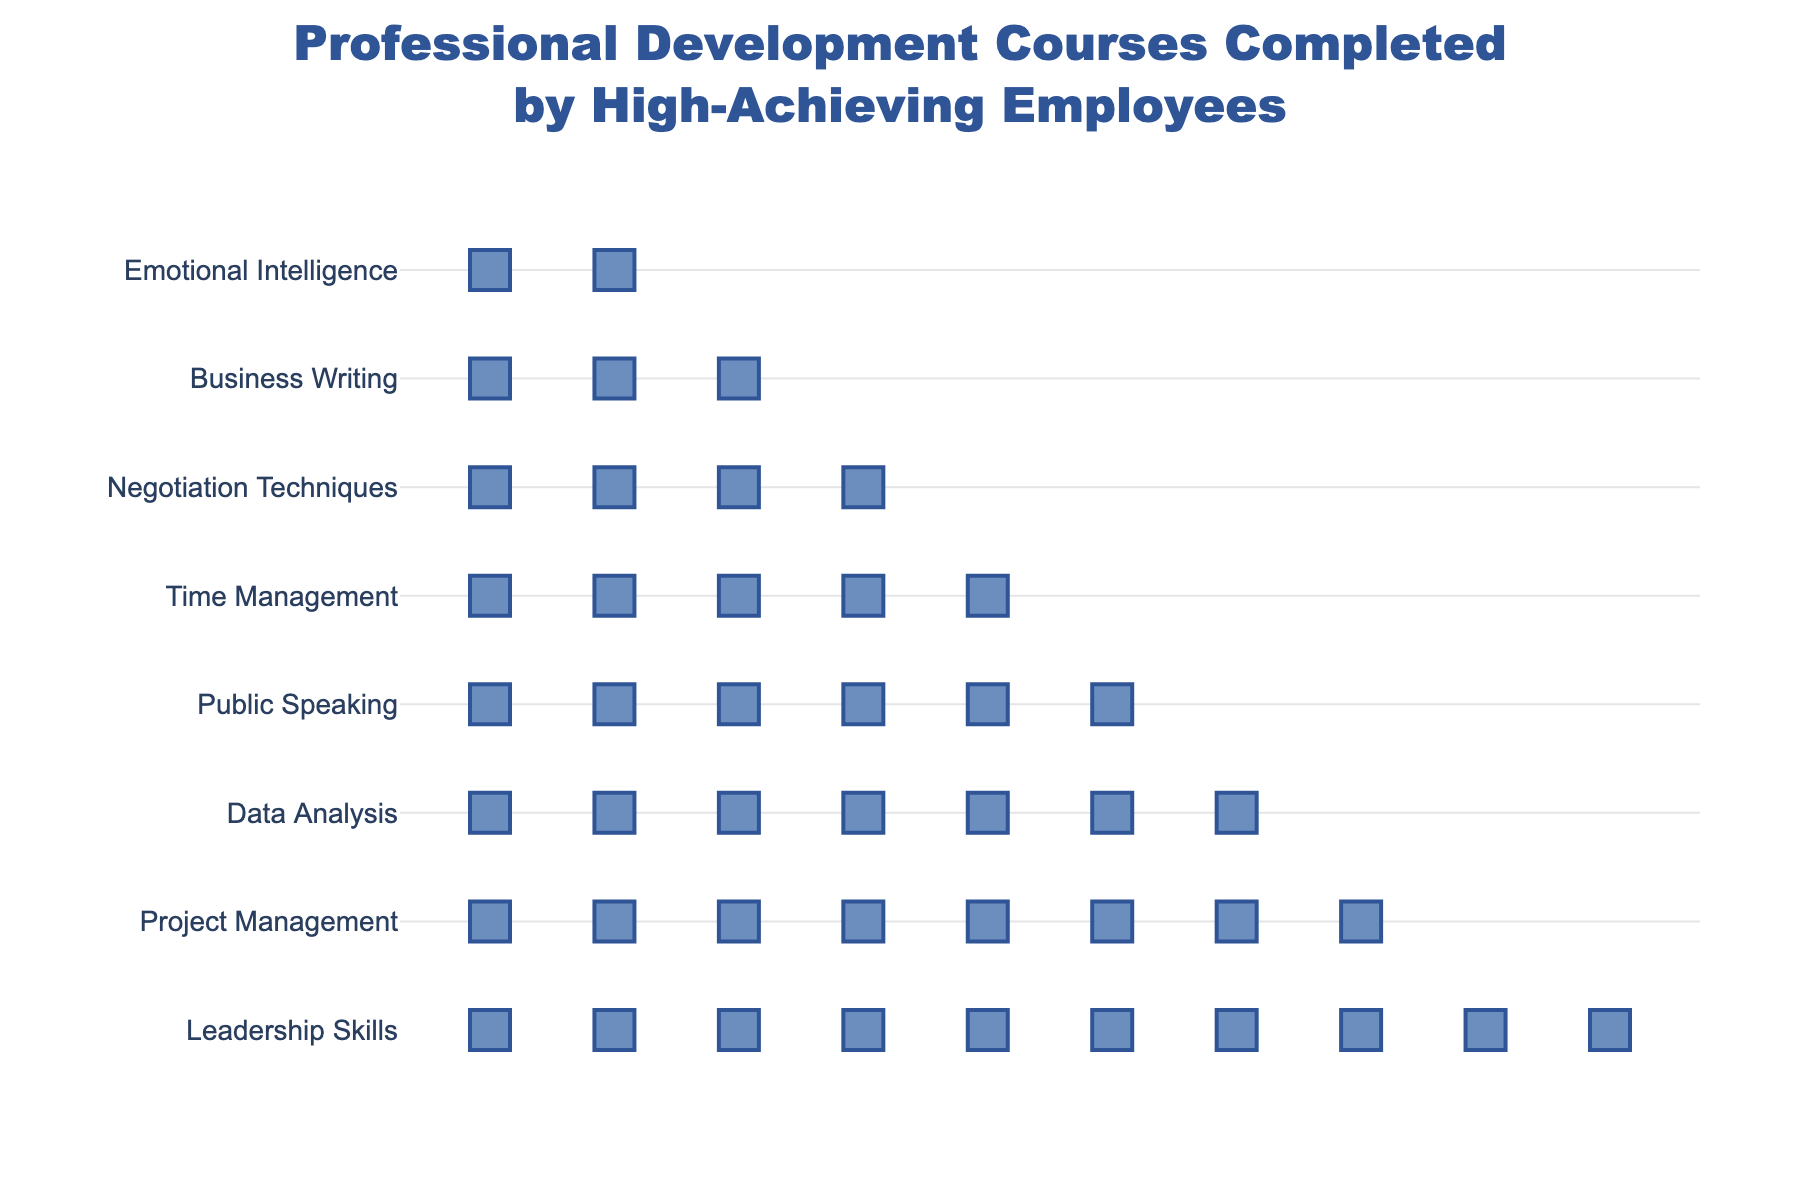which course has the highest number of completions? The title provides the breakdown for each course. By counting the icons or referring to the hover text, "Leadership Skills" has the most completions.
Answer: Leadership Skills How many more completions does Leadership Skills have compared to Emotional Intelligence? "Leadership Skills" has 50 completions, while "Emotional Intelligence" has 10 completions. The difference is 50 - 10.
Answer: 40 How many total icons represent Data Analysis? Each icon represents 5 completions. "Data Analysis" has 35 completions, which is 35 / 5.
Answer: 7 What is the combined number of completions for the top three most completed courses? Top three courses: Leadership Skills (50), Project Management (40), Data Analysis (35). The combined total is 50 + 40 + 35.
Answer: 125 Which courses have fewer than 30 completions? Viewing the figure, courses with fewer than 30 completions are Time Management, Negotiation Techniques, Business Writing, and Emotional Intelligence.
Answer: Time Management, Negotiation Techniques, Business Writing, Emotional Intelligence How many completions are there in total across all courses? Summing up all completions: 50 + 40 + 35 + 30 + 25 + 20 + 15 + 10.
Answer: 225 What is the average number of completions per course? Total completions are 225, and there are 8 courses. The average is 225 / 8.
Answer: 28.125 Which course has exactly 6 icons? Each icon stands for 5 completions. A course with 6 icons represents 6 * 5 = 30 completions. "Public Speaking" fits this.
Answer: Public Speaking 